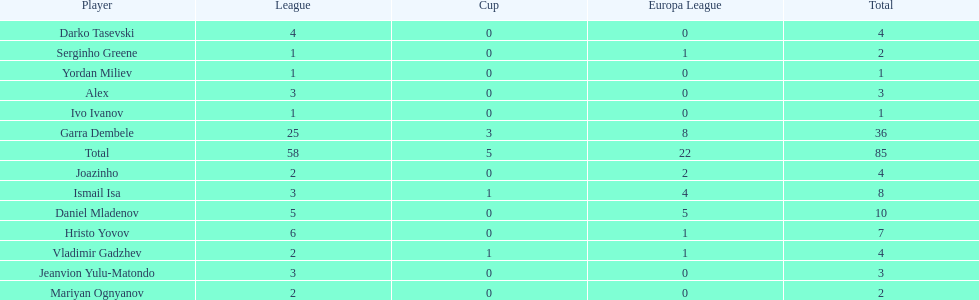What is the difference between vladimir gadzhev and yordan miliev's scores? 3. 